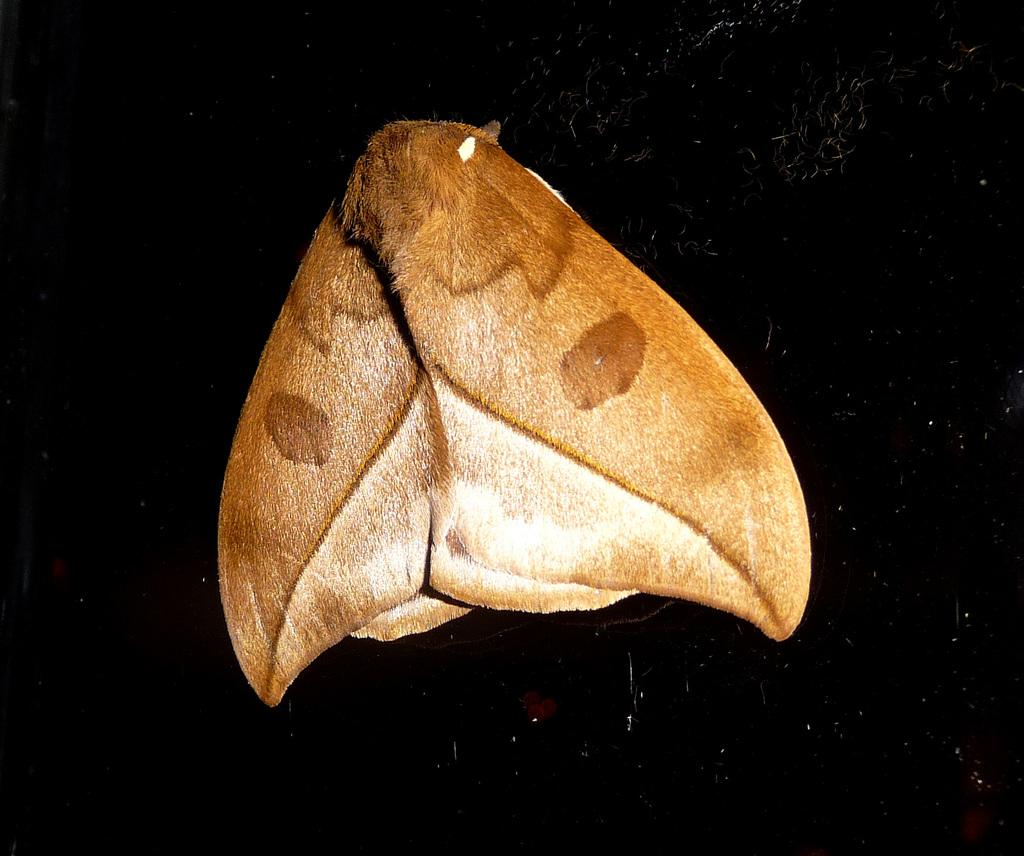What type of insect is present in the image? There is a fly in the image. What type of polish is the fly using to shine its wings in the image? There is no polish or indication of wing-shining in the image; it simply shows a fly. 